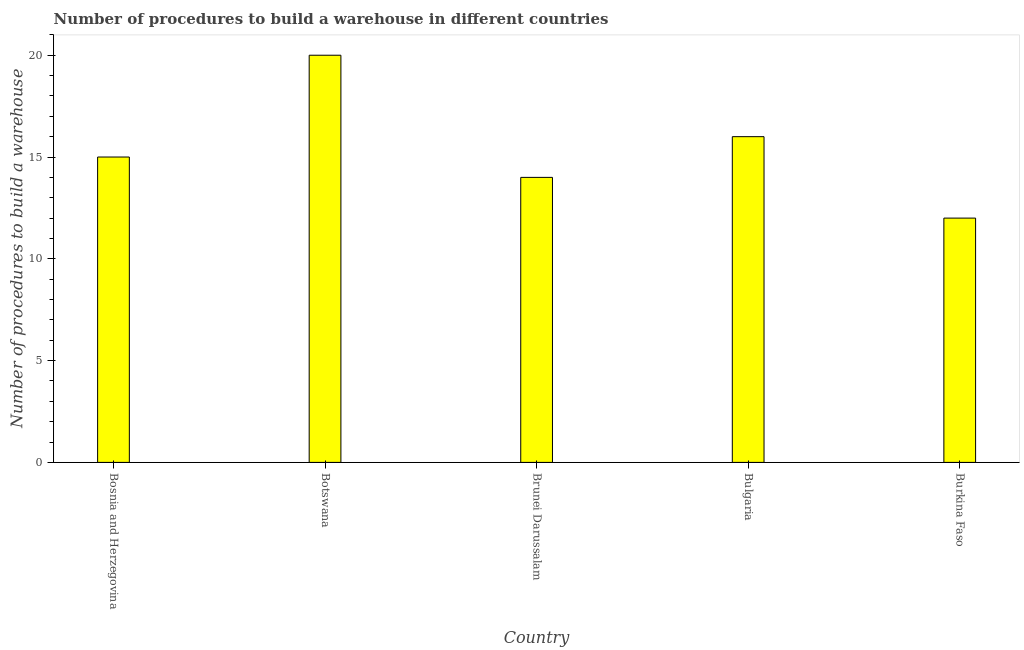Does the graph contain any zero values?
Provide a short and direct response. No. What is the title of the graph?
Give a very brief answer. Number of procedures to build a warehouse in different countries. What is the label or title of the Y-axis?
Offer a terse response. Number of procedures to build a warehouse. What is the number of procedures to build a warehouse in Burkina Faso?
Ensure brevity in your answer.  12. Across all countries, what is the maximum number of procedures to build a warehouse?
Your answer should be compact. 20. In which country was the number of procedures to build a warehouse maximum?
Give a very brief answer. Botswana. In which country was the number of procedures to build a warehouse minimum?
Keep it short and to the point. Burkina Faso. What is the sum of the number of procedures to build a warehouse?
Your answer should be compact. 77. Is the number of procedures to build a warehouse in Botswana less than that in Bulgaria?
Ensure brevity in your answer.  No. Is the difference between the number of procedures to build a warehouse in Brunei Darussalam and Burkina Faso greater than the difference between any two countries?
Ensure brevity in your answer.  No. What is the difference between the highest and the second highest number of procedures to build a warehouse?
Ensure brevity in your answer.  4. How many bars are there?
Offer a terse response. 5. Are all the bars in the graph horizontal?
Your response must be concise. No. How many countries are there in the graph?
Ensure brevity in your answer.  5. What is the difference between two consecutive major ticks on the Y-axis?
Provide a short and direct response. 5. Are the values on the major ticks of Y-axis written in scientific E-notation?
Your answer should be very brief. No. What is the Number of procedures to build a warehouse of Bosnia and Herzegovina?
Keep it short and to the point. 15. What is the Number of procedures to build a warehouse in Brunei Darussalam?
Ensure brevity in your answer.  14. What is the Number of procedures to build a warehouse in Burkina Faso?
Your answer should be compact. 12. What is the difference between the Number of procedures to build a warehouse in Bosnia and Herzegovina and Brunei Darussalam?
Provide a short and direct response. 1. What is the difference between the Number of procedures to build a warehouse in Bosnia and Herzegovina and Bulgaria?
Keep it short and to the point. -1. What is the difference between the Number of procedures to build a warehouse in Bulgaria and Burkina Faso?
Your answer should be very brief. 4. What is the ratio of the Number of procedures to build a warehouse in Bosnia and Herzegovina to that in Brunei Darussalam?
Your answer should be compact. 1.07. What is the ratio of the Number of procedures to build a warehouse in Bosnia and Herzegovina to that in Bulgaria?
Provide a succinct answer. 0.94. What is the ratio of the Number of procedures to build a warehouse in Botswana to that in Brunei Darussalam?
Your response must be concise. 1.43. What is the ratio of the Number of procedures to build a warehouse in Botswana to that in Burkina Faso?
Provide a short and direct response. 1.67. What is the ratio of the Number of procedures to build a warehouse in Brunei Darussalam to that in Bulgaria?
Provide a succinct answer. 0.88. What is the ratio of the Number of procedures to build a warehouse in Brunei Darussalam to that in Burkina Faso?
Offer a very short reply. 1.17. What is the ratio of the Number of procedures to build a warehouse in Bulgaria to that in Burkina Faso?
Offer a terse response. 1.33. 